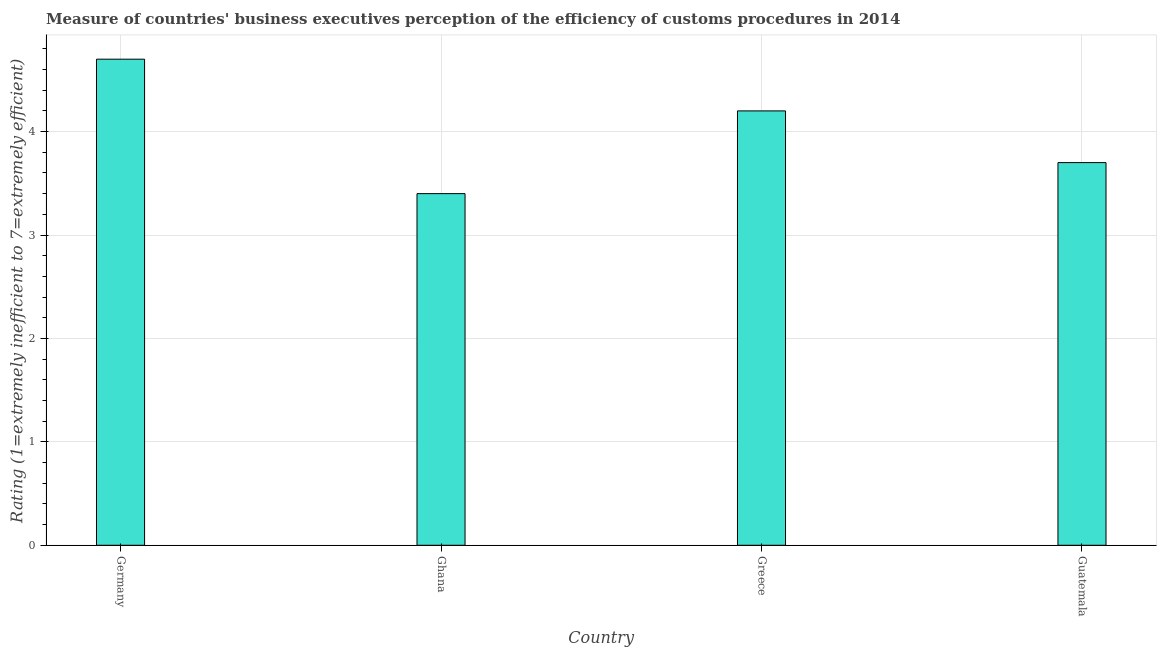Does the graph contain any zero values?
Provide a short and direct response. No. Does the graph contain grids?
Offer a terse response. Yes. What is the title of the graph?
Offer a terse response. Measure of countries' business executives perception of the efficiency of customs procedures in 2014. What is the label or title of the Y-axis?
Ensure brevity in your answer.  Rating (1=extremely inefficient to 7=extremely efficient). Across all countries, what is the maximum rating measuring burden of customs procedure?
Your response must be concise. 4.7. Across all countries, what is the minimum rating measuring burden of customs procedure?
Keep it short and to the point. 3.4. In which country was the rating measuring burden of customs procedure maximum?
Make the answer very short. Germany. In which country was the rating measuring burden of customs procedure minimum?
Your answer should be compact. Ghana. What is the average rating measuring burden of customs procedure per country?
Provide a succinct answer. 4. What is the median rating measuring burden of customs procedure?
Offer a terse response. 3.95. In how many countries, is the rating measuring burden of customs procedure greater than 2 ?
Your response must be concise. 4. What is the ratio of the rating measuring burden of customs procedure in Ghana to that in Guatemala?
Ensure brevity in your answer.  0.92. Is the rating measuring burden of customs procedure in Ghana less than that in Guatemala?
Keep it short and to the point. Yes. Is the difference between the rating measuring burden of customs procedure in Germany and Ghana greater than the difference between any two countries?
Provide a short and direct response. Yes. What is the difference between the highest and the lowest rating measuring burden of customs procedure?
Provide a short and direct response. 1.3. In how many countries, is the rating measuring burden of customs procedure greater than the average rating measuring burden of customs procedure taken over all countries?
Keep it short and to the point. 2. Are all the bars in the graph horizontal?
Ensure brevity in your answer.  No. How many countries are there in the graph?
Offer a terse response. 4. What is the difference between two consecutive major ticks on the Y-axis?
Your response must be concise. 1. Are the values on the major ticks of Y-axis written in scientific E-notation?
Provide a short and direct response. No. What is the Rating (1=extremely inefficient to 7=extremely efficient) of Germany?
Offer a very short reply. 4.7. What is the Rating (1=extremely inefficient to 7=extremely efficient) in Ghana?
Keep it short and to the point. 3.4. What is the Rating (1=extremely inefficient to 7=extremely efficient) of Guatemala?
Your response must be concise. 3.7. What is the difference between the Rating (1=extremely inefficient to 7=extremely efficient) in Germany and Greece?
Give a very brief answer. 0.5. What is the difference between the Rating (1=extremely inefficient to 7=extremely efficient) in Germany and Guatemala?
Make the answer very short. 1. What is the difference between the Rating (1=extremely inefficient to 7=extremely efficient) in Ghana and Greece?
Keep it short and to the point. -0.8. What is the difference between the Rating (1=extremely inefficient to 7=extremely efficient) in Ghana and Guatemala?
Offer a very short reply. -0.3. What is the difference between the Rating (1=extremely inefficient to 7=extremely efficient) in Greece and Guatemala?
Offer a terse response. 0.5. What is the ratio of the Rating (1=extremely inefficient to 7=extremely efficient) in Germany to that in Ghana?
Your answer should be compact. 1.38. What is the ratio of the Rating (1=extremely inefficient to 7=extremely efficient) in Germany to that in Greece?
Ensure brevity in your answer.  1.12. What is the ratio of the Rating (1=extremely inefficient to 7=extremely efficient) in Germany to that in Guatemala?
Your response must be concise. 1.27. What is the ratio of the Rating (1=extremely inefficient to 7=extremely efficient) in Ghana to that in Greece?
Your answer should be very brief. 0.81. What is the ratio of the Rating (1=extremely inefficient to 7=extremely efficient) in Ghana to that in Guatemala?
Offer a terse response. 0.92. What is the ratio of the Rating (1=extremely inefficient to 7=extremely efficient) in Greece to that in Guatemala?
Offer a terse response. 1.14. 